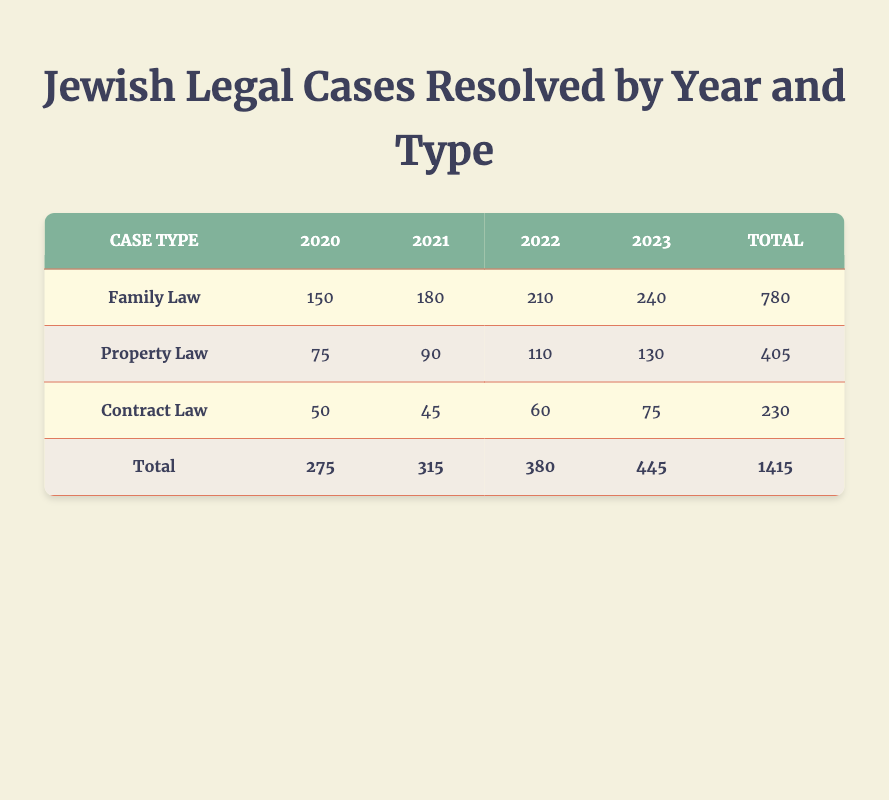What was the total number of resolved Family Law cases in 2021? To find the total number of resolved Family Law cases in 2021, we can directly refer to the row for Family Law and the column for the year 2021, which states 180 resolved cases.
Answer: 180 How many more Property Law cases were resolved in 2023 compared to 2020? To find this, we take the number of resolved Property Law cases in 2023 (130) and subtract the number of resolved Property Law cases in 2020 (75). Thus, 130 - 75 = 55 cases were resolved in 2023 compared to 2020.
Answer: 55 Is it true that the total number of Contract Law cases resolved in 2022 was greater than in 2021? We look at the resolved cases for Contract Law, noting 60 in 2022 and 45 in 2021. Since 60 is greater than 45, the statement is true.
Answer: Yes What is the average number of resolved Family Law cases over the four years from 2020 to 2023? To find the average, we add the resolved Family Law cases for each year (150 + 180 + 210 + 240 = 780) and divide by the number of years (4). So, 780 / 4 = 195 is the average number of resolved Family Law cases.
Answer: 195 Which year saw the highest total number of resolved legal cases across all types? To determine the highest total, we need to find the total resolved cases for each year: 2020 (275), 2021 (315), 2022 (380), 2023 (445). The highest total is 445 in 2023.
Answer: 2023 How many resolved cases of Contract Law were there in 2020 and 2021 combined? Adding the resolved Contract Law cases for 2020 (50) and 2021 (45) gives us a total of 50 + 45 = 95 cases for those two years combined.
Answer: 95 Which case type had the lowest total resolved cases over the four years? We compare the total resolved cases for each case type: Family Law (780), Property Law (405), and Contract Law (230). The lowest total is for Contract Law at 230 cases.
Answer: Contract Law In which year did the number of resolved Family Law cases first exceed 200? By examining the resolved Family Law cases, we see that the first year to exceed 200 cases is 2022, as the figures are 150 (2020), 180 (2021), 210 (2022).
Answer: 2022 